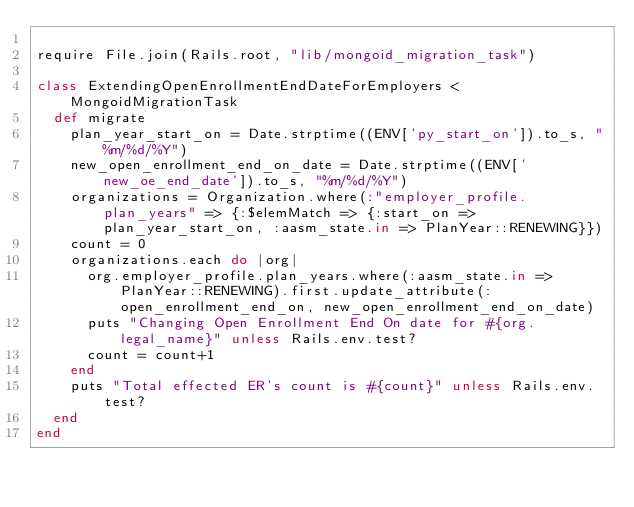Convert code to text. <code><loc_0><loc_0><loc_500><loc_500><_Ruby_>
require File.join(Rails.root, "lib/mongoid_migration_task")

class ExtendingOpenEnrollmentEndDateForEmployers < MongoidMigrationTask
  def migrate
    plan_year_start_on = Date.strptime((ENV['py_start_on']).to_s, "%m/%d/%Y")
    new_open_enrollment_end_on_date = Date.strptime((ENV['new_oe_end_date']).to_s, "%m/%d/%Y")
    organizations = Organization.where(:"employer_profile.plan_years" => {:$elemMatch => {:start_on => plan_year_start_on, :aasm_state.in => PlanYear::RENEWING}})
    count = 0
    organizations.each do |org|
      org.employer_profile.plan_years.where(:aasm_state.in => PlanYear::RENEWING).first.update_attribute(:open_enrollment_end_on, new_open_enrollment_end_on_date)
      puts "Changing Open Enrollment End On date for #{org.legal_name}" unless Rails.env.test?
      count = count+1
    end
    puts "Total effected ER's count is #{count}" unless Rails.env.test?
  end
end
</code> 